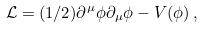Convert formula to latex. <formula><loc_0><loc_0><loc_500><loc_500>\mathcal { L } = ( 1 / 2 ) \partial ^ { \mu } \phi \partial _ { \mu } \phi - V ( \phi ) \, ,</formula> 